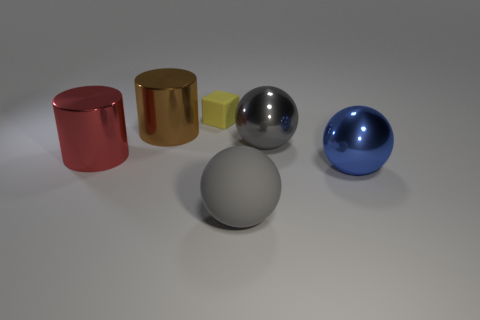Subtract all yellow cylinders. How many gray balls are left? 2 Add 1 cylinders. How many objects exist? 7 Subtract all cylinders. How many objects are left? 4 Add 4 big blue metallic things. How many big blue metallic things are left? 5 Add 1 large gray matte cylinders. How many large gray matte cylinders exist? 1 Subtract 0 gray cylinders. How many objects are left? 6 Subtract all large rubber balls. Subtract all big gray spheres. How many objects are left? 3 